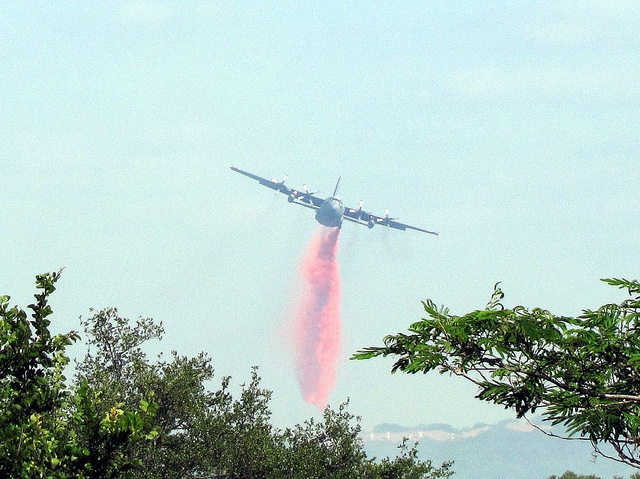Describe the objects in this image and their specific colors. I can see a airplane in lightblue, gray, lightgray, and darkgray tones in this image. 